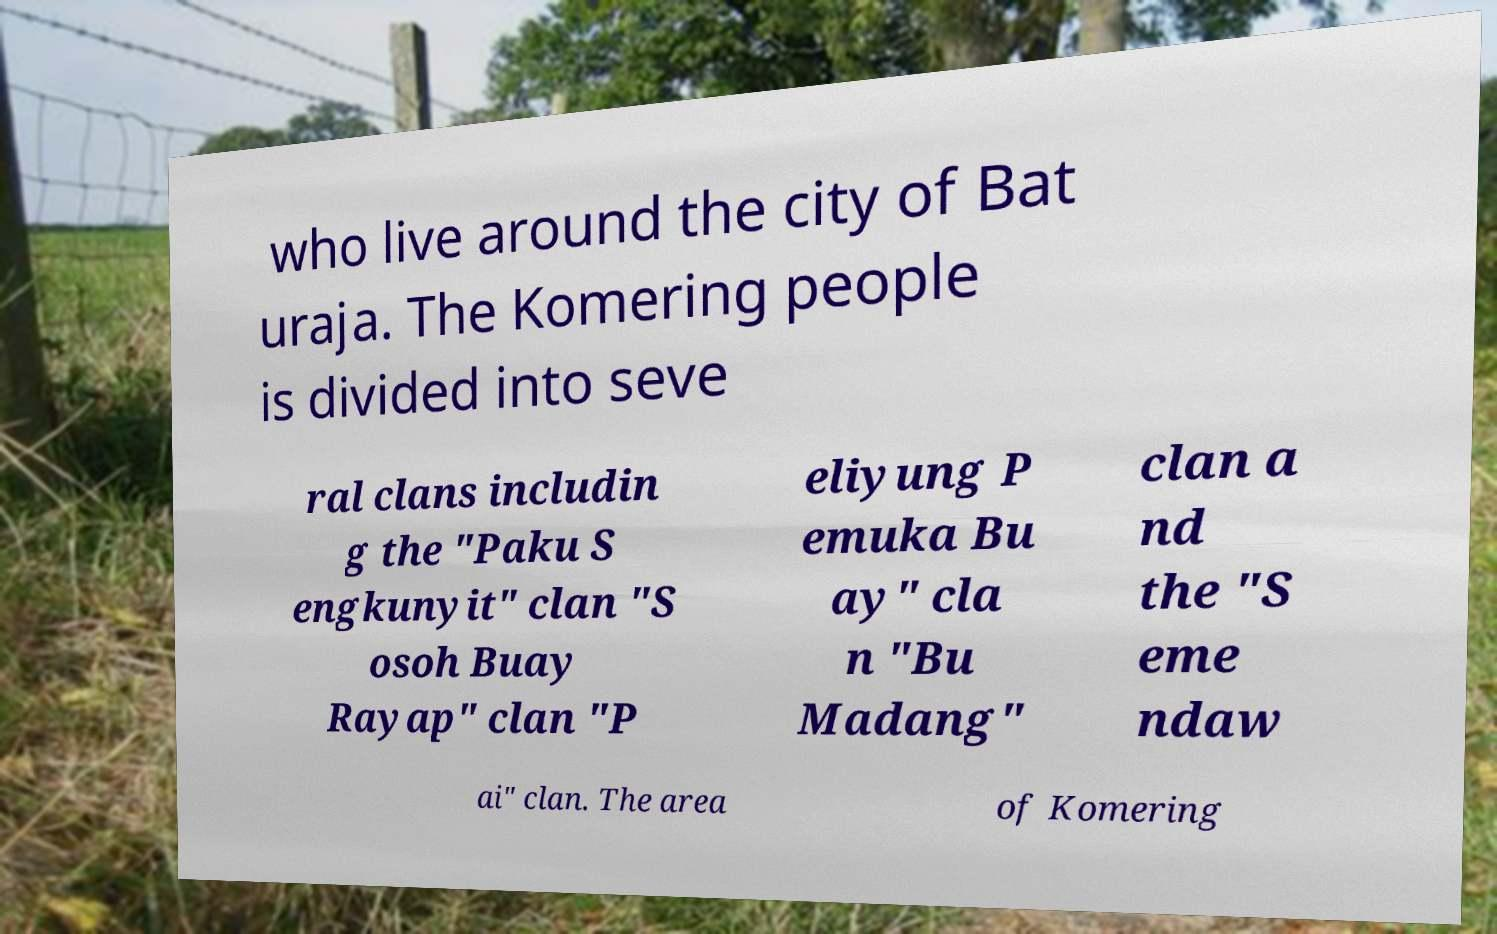Please identify and transcribe the text found in this image. who live around the city of Bat uraja. The Komering people is divided into seve ral clans includin g the "Paku S engkunyit" clan "S osoh Buay Rayap" clan "P eliyung P emuka Bu ay" cla n "Bu Madang" clan a nd the "S eme ndaw ai" clan. The area of Komering 